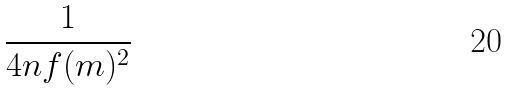<formula> <loc_0><loc_0><loc_500><loc_500>\frac { 1 } { 4 n f ( m ) ^ { 2 } }</formula> 